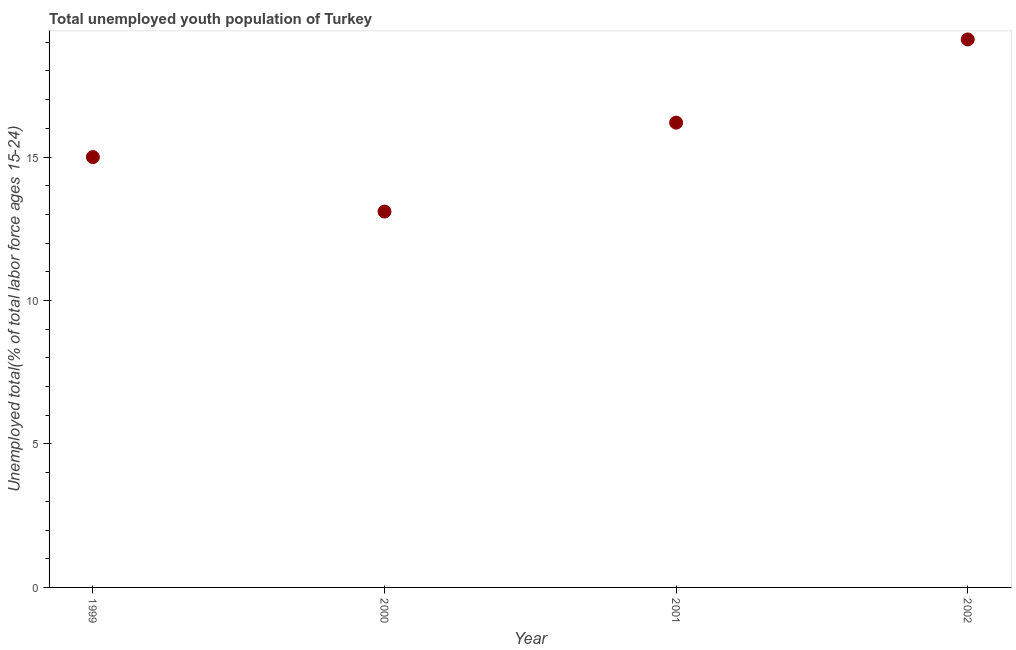What is the unemployed youth in 1999?
Make the answer very short. 15. Across all years, what is the maximum unemployed youth?
Your answer should be very brief. 19.1. Across all years, what is the minimum unemployed youth?
Provide a short and direct response. 13.1. In which year was the unemployed youth maximum?
Provide a succinct answer. 2002. What is the sum of the unemployed youth?
Make the answer very short. 63.4. What is the difference between the unemployed youth in 2000 and 2001?
Your answer should be very brief. -3.1. What is the average unemployed youth per year?
Make the answer very short. 15.85. What is the median unemployed youth?
Ensure brevity in your answer.  15.6. In how many years, is the unemployed youth greater than 2 %?
Make the answer very short. 4. What is the ratio of the unemployed youth in 1999 to that in 2001?
Provide a short and direct response. 0.93. What is the difference between the highest and the second highest unemployed youth?
Make the answer very short. 2.9. What is the difference between the highest and the lowest unemployed youth?
Offer a very short reply. 6. In how many years, is the unemployed youth greater than the average unemployed youth taken over all years?
Your answer should be compact. 2. Does the unemployed youth monotonically increase over the years?
Your response must be concise. No. How many years are there in the graph?
Your answer should be compact. 4. Does the graph contain any zero values?
Keep it short and to the point. No. What is the title of the graph?
Provide a short and direct response. Total unemployed youth population of Turkey. What is the label or title of the X-axis?
Keep it short and to the point. Year. What is the label or title of the Y-axis?
Give a very brief answer. Unemployed total(% of total labor force ages 15-24). What is the Unemployed total(% of total labor force ages 15-24) in 2000?
Offer a very short reply. 13.1. What is the Unemployed total(% of total labor force ages 15-24) in 2001?
Ensure brevity in your answer.  16.2. What is the Unemployed total(% of total labor force ages 15-24) in 2002?
Provide a short and direct response. 19.1. What is the difference between the Unemployed total(% of total labor force ages 15-24) in 2000 and 2001?
Make the answer very short. -3.1. What is the difference between the Unemployed total(% of total labor force ages 15-24) in 2000 and 2002?
Your answer should be very brief. -6. What is the difference between the Unemployed total(% of total labor force ages 15-24) in 2001 and 2002?
Offer a terse response. -2.9. What is the ratio of the Unemployed total(% of total labor force ages 15-24) in 1999 to that in 2000?
Your answer should be very brief. 1.15. What is the ratio of the Unemployed total(% of total labor force ages 15-24) in 1999 to that in 2001?
Keep it short and to the point. 0.93. What is the ratio of the Unemployed total(% of total labor force ages 15-24) in 1999 to that in 2002?
Your answer should be compact. 0.79. What is the ratio of the Unemployed total(% of total labor force ages 15-24) in 2000 to that in 2001?
Provide a short and direct response. 0.81. What is the ratio of the Unemployed total(% of total labor force ages 15-24) in 2000 to that in 2002?
Keep it short and to the point. 0.69. What is the ratio of the Unemployed total(% of total labor force ages 15-24) in 2001 to that in 2002?
Offer a terse response. 0.85. 